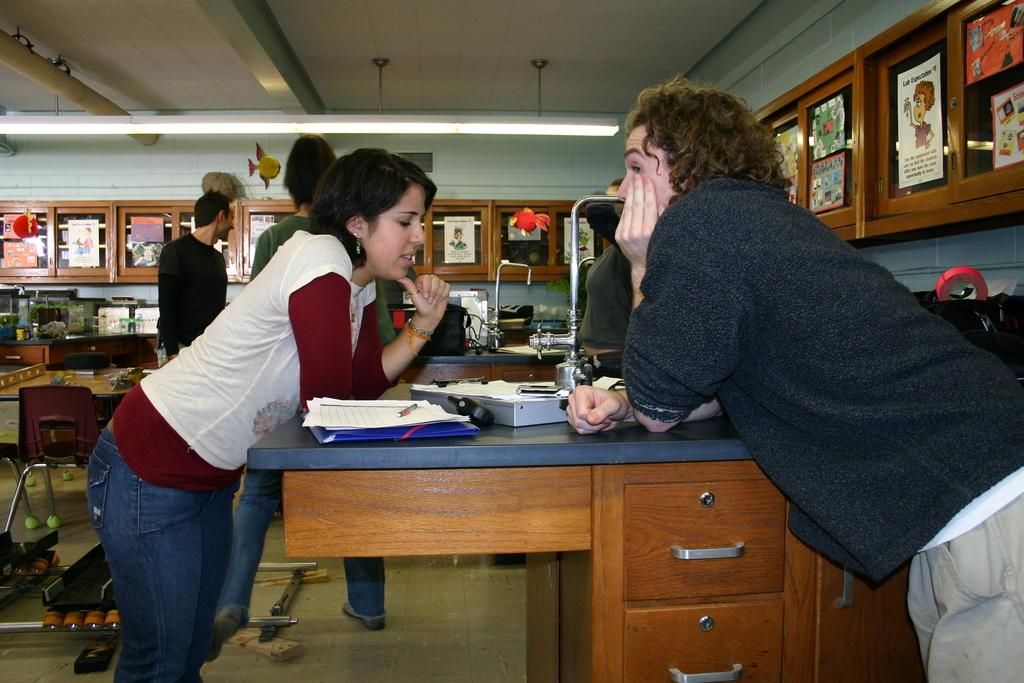How many people are in the image? There are 2 people in the image. What are the people doing with their hands? The people have their hands on the table. What objects can be seen on the table? There is a book and a pen on the table. What can be seen in the background of the image? There are people, cupboards, a wall, and light in the background of the image. What type of furniture is visible in the background? There are chairs in the background of the image. What type of wine is being served in the image? There is no wine present in the image. Can you see the badge on the person's uniform in the image? There is no mention of a uniform or badge in the image. 